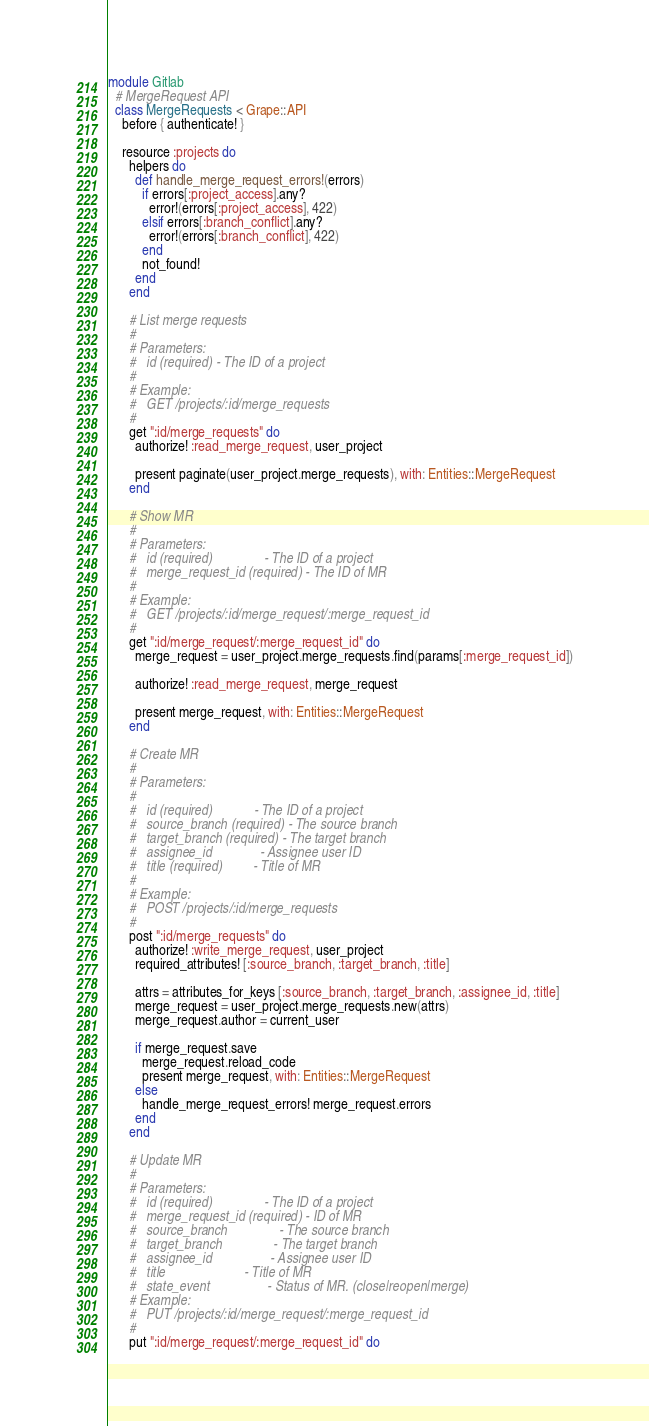Convert code to text. <code><loc_0><loc_0><loc_500><loc_500><_Ruby_>module Gitlab
  # MergeRequest API
  class MergeRequests < Grape::API
    before { authenticate! }

    resource :projects do
      helpers do
        def handle_merge_request_errors!(errors)
          if errors[:project_access].any?
            error!(errors[:project_access], 422)
          elsif errors[:branch_conflict].any?
            error!(errors[:branch_conflict], 422)
          end
          not_found!
        end
      end

      # List merge requests
      #
      # Parameters:
      #   id (required) - The ID of a project
      #
      # Example:
      #   GET /projects/:id/merge_requests
      #
      get ":id/merge_requests" do
        authorize! :read_merge_request, user_project

        present paginate(user_project.merge_requests), with: Entities::MergeRequest
      end

      # Show MR
      #
      # Parameters:
      #   id (required)               - The ID of a project
      #   merge_request_id (required) - The ID of MR
      #
      # Example:
      #   GET /projects/:id/merge_request/:merge_request_id
      #
      get ":id/merge_request/:merge_request_id" do
        merge_request = user_project.merge_requests.find(params[:merge_request_id])

        authorize! :read_merge_request, merge_request

        present merge_request, with: Entities::MergeRequest
      end

      # Create MR
      #
      # Parameters:
      #
      #   id (required)            - The ID of a project
      #   source_branch (required) - The source branch
      #   target_branch (required) - The target branch
      #   assignee_id              - Assignee user ID
      #   title (required)         - Title of MR
      #
      # Example:
      #   POST /projects/:id/merge_requests
      #
      post ":id/merge_requests" do
        authorize! :write_merge_request, user_project
        required_attributes! [:source_branch, :target_branch, :title]

        attrs = attributes_for_keys [:source_branch, :target_branch, :assignee_id, :title]
        merge_request = user_project.merge_requests.new(attrs)
        merge_request.author = current_user

        if merge_request.save
          merge_request.reload_code
          present merge_request, with: Entities::MergeRequest
        else
          handle_merge_request_errors! merge_request.errors
        end
      end

      # Update MR
      #
      # Parameters:
      #   id (required)               - The ID of a project
      #   merge_request_id (required) - ID of MR
      #   source_branch               - The source branch
      #   target_branch               - The target branch
      #   assignee_id                 - Assignee user ID
      #   title                       - Title of MR
      #   state_event                 - Status of MR. (close|reopen|merge)
      # Example:
      #   PUT /projects/:id/merge_request/:merge_request_id
      #
      put ":id/merge_request/:merge_request_id" do</code> 